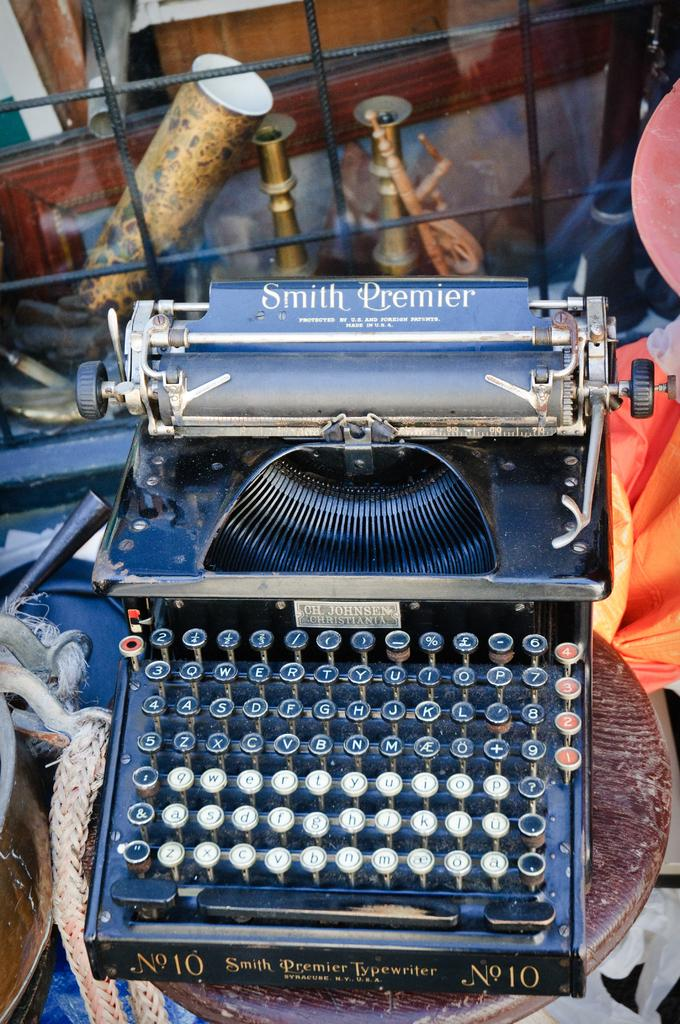<image>
Offer a succinct explanation of the picture presented. A typewriter, made by Smith Premier, has black and white keys. 